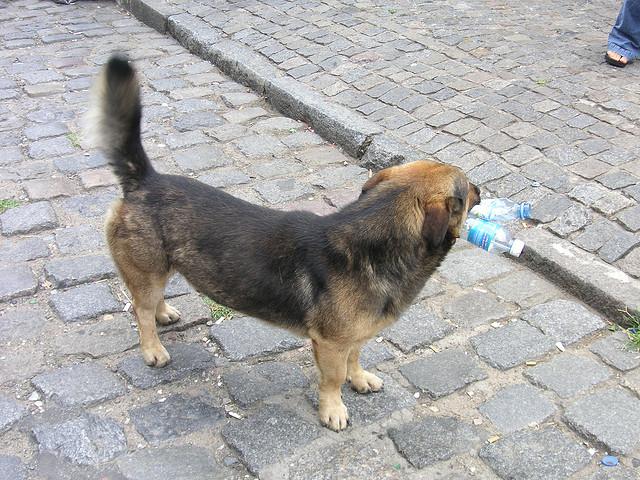What is the dog doing?
Answer briefly. Carrying bottles. What is in the dog's mouth?
Quick response, please. Bottles. What is the dog looking at the camera?
Answer briefly. No. 